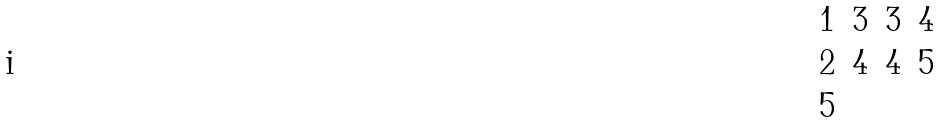<formula> <loc_0><loc_0><loc_500><loc_500>\begin{matrix} 1 & 3 & 3 & 4 \\ 2 & 4 & 4 & 5 \\ 5 & & & \end{matrix}</formula> 